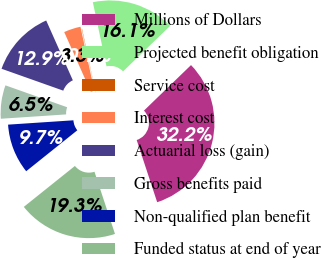Convert chart. <chart><loc_0><loc_0><loc_500><loc_500><pie_chart><fcel>Millions of Dollars<fcel>Projected benefit obligation<fcel>Service cost<fcel>Interest cost<fcel>Actuarial loss (gain)<fcel>Gross benefits paid<fcel>Non-qualified plan benefit<fcel>Funded status at end of year<nl><fcel>32.16%<fcel>16.11%<fcel>0.06%<fcel>3.27%<fcel>12.9%<fcel>6.48%<fcel>9.69%<fcel>19.32%<nl></chart> 